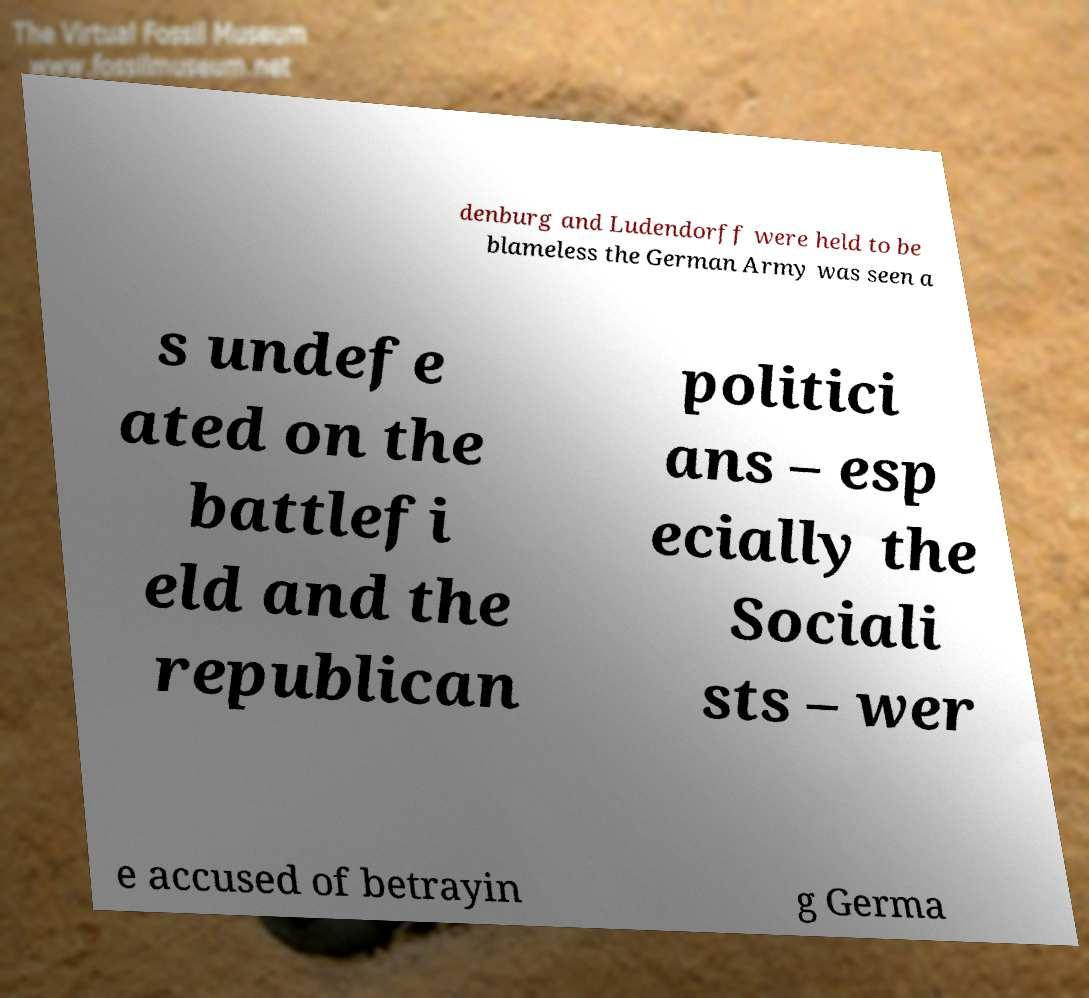For documentation purposes, I need the text within this image transcribed. Could you provide that? denburg and Ludendorff were held to be blameless the German Army was seen a s undefe ated on the battlefi eld and the republican politici ans – esp ecially the Sociali sts – wer e accused of betrayin g Germa 